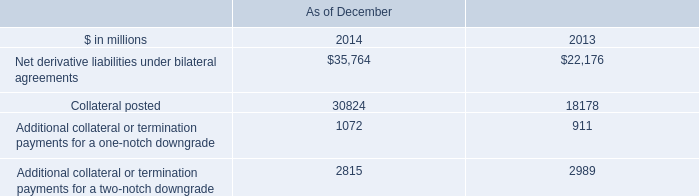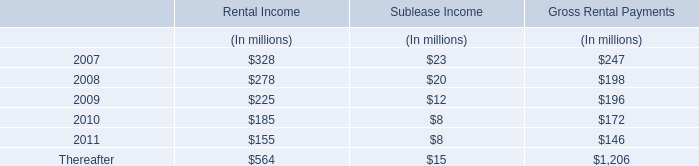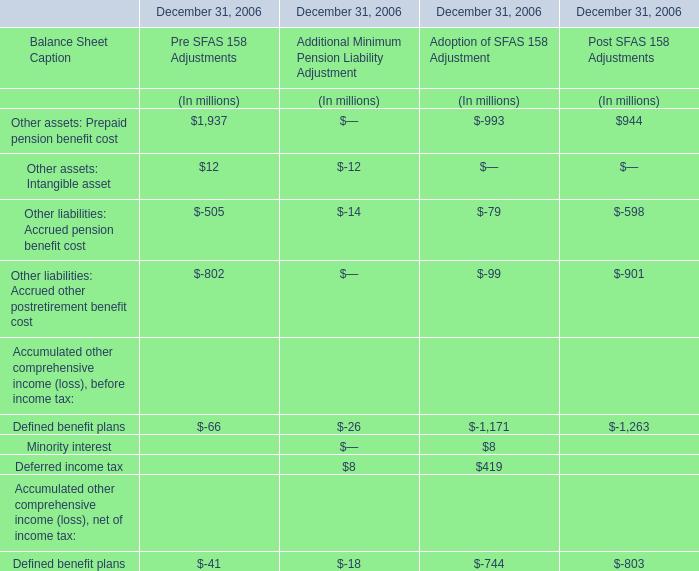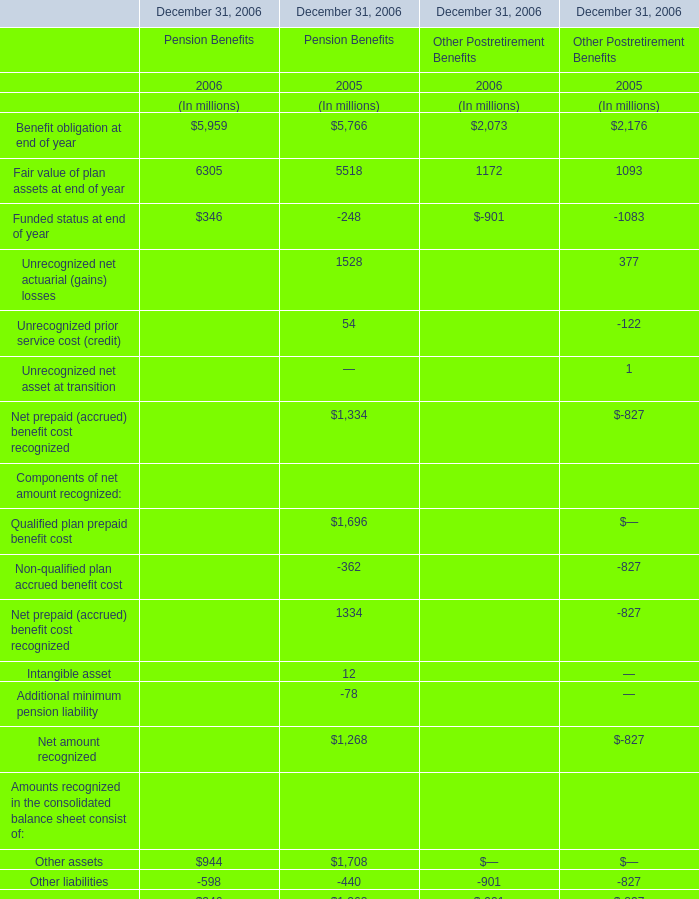In which year is Net prepaid (accrued) benefit cost recognized for Pension Benefits positive? 
Answer: 2005. 